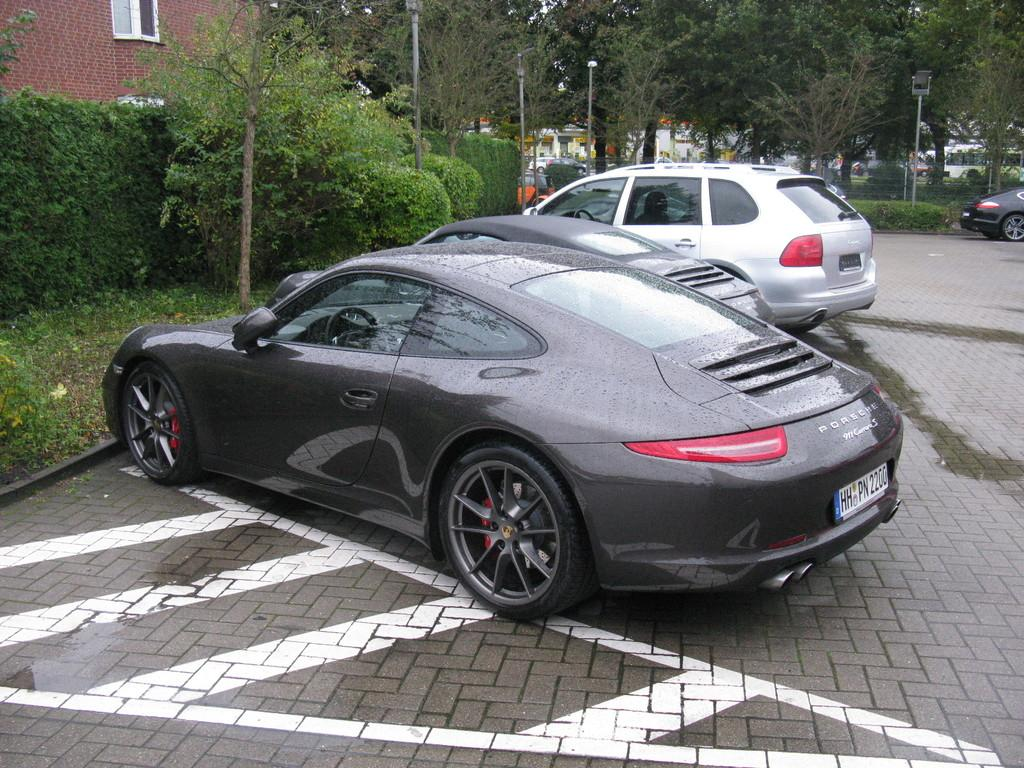What type of vehicles can be seen on the road in the image? There are cars on the road in the image. What type of vegetation is present in the image? There are plants, trees, and bushes in the image. What structures can be seen in the background of the image? There are buildings and light poles in the background of the image. How many types of vehicles can be seen in the image? There are cars on the road, and there are vehicles in the background, so there are at least two types of vehicles visible. Can you hear a whistle in the image? There is no auditory element in the image, so it is not possible to hear a whistle or any other sound. 